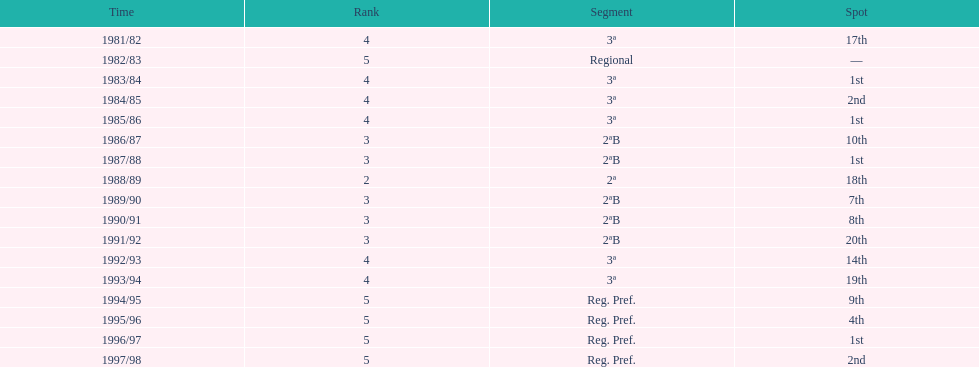Which season(s) earned first place? 1983/84, 1985/86, 1987/88, 1996/97. 